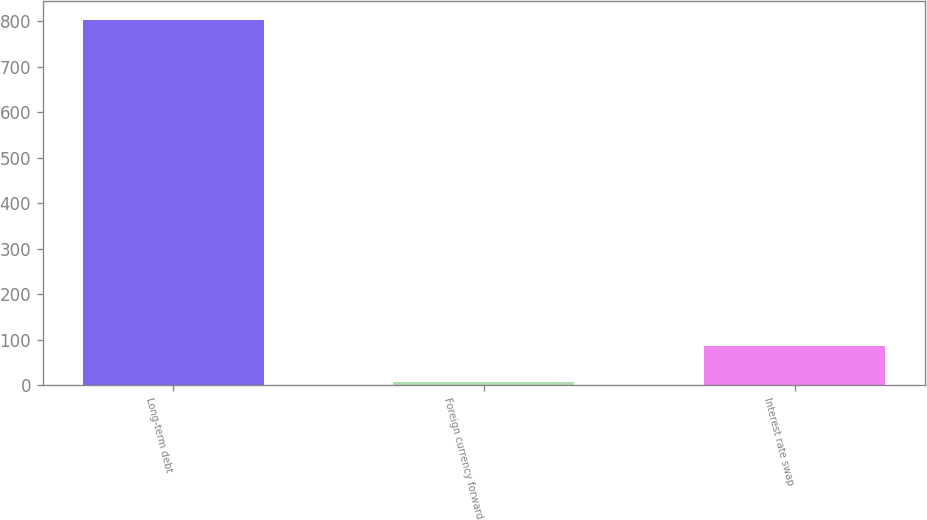<chart> <loc_0><loc_0><loc_500><loc_500><bar_chart><fcel>Long-term debt<fcel>Foreign currency forward<fcel>Interest rate swap<nl><fcel>803.7<fcel>6.6<fcel>86.31<nl></chart> 